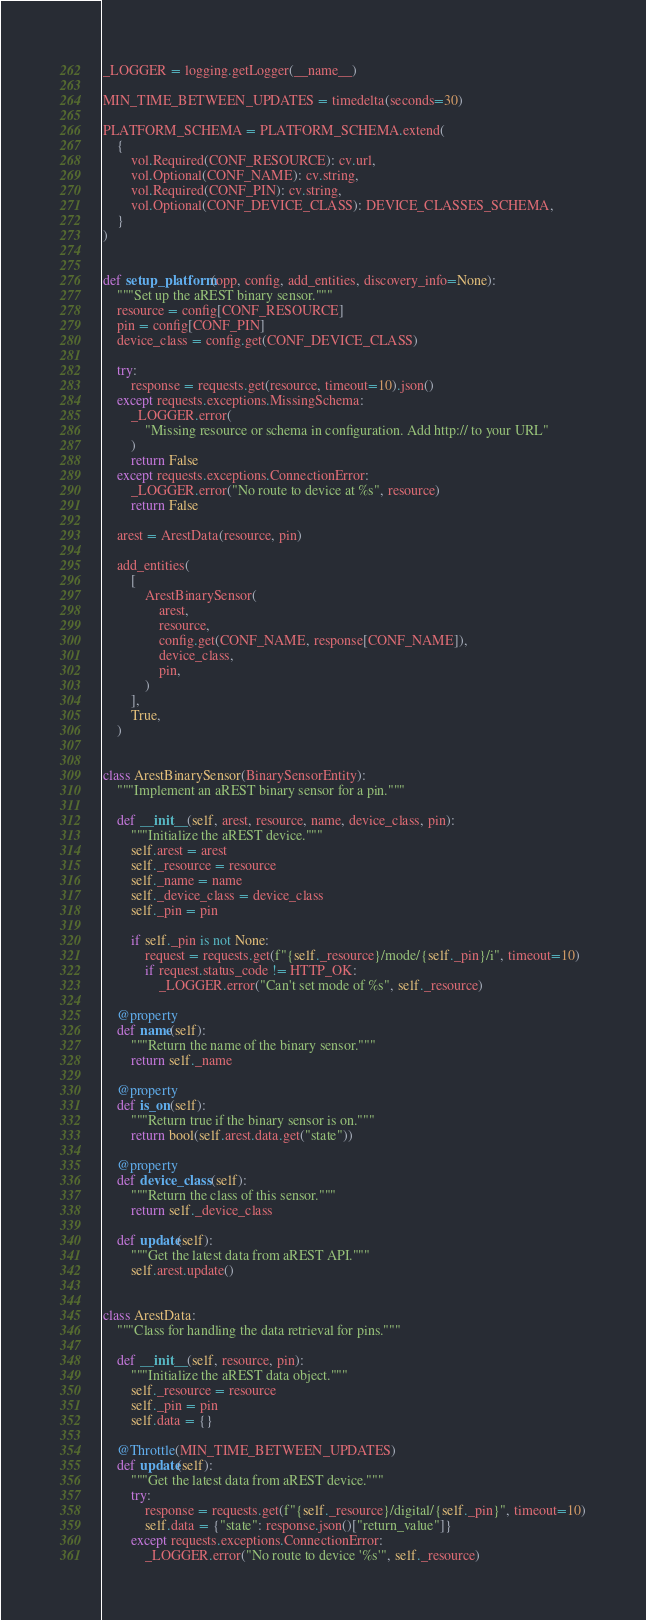<code> <loc_0><loc_0><loc_500><loc_500><_Python_>
_LOGGER = logging.getLogger(__name__)

MIN_TIME_BETWEEN_UPDATES = timedelta(seconds=30)

PLATFORM_SCHEMA = PLATFORM_SCHEMA.extend(
    {
        vol.Required(CONF_RESOURCE): cv.url,
        vol.Optional(CONF_NAME): cv.string,
        vol.Required(CONF_PIN): cv.string,
        vol.Optional(CONF_DEVICE_CLASS): DEVICE_CLASSES_SCHEMA,
    }
)


def setup_platform(opp, config, add_entities, discovery_info=None):
    """Set up the aREST binary sensor."""
    resource = config[CONF_RESOURCE]
    pin = config[CONF_PIN]
    device_class = config.get(CONF_DEVICE_CLASS)

    try:
        response = requests.get(resource, timeout=10).json()
    except requests.exceptions.MissingSchema:
        _LOGGER.error(
            "Missing resource or schema in configuration. Add http:// to your URL"
        )
        return False
    except requests.exceptions.ConnectionError:
        _LOGGER.error("No route to device at %s", resource)
        return False

    arest = ArestData(resource, pin)

    add_entities(
        [
            ArestBinarySensor(
                arest,
                resource,
                config.get(CONF_NAME, response[CONF_NAME]),
                device_class,
                pin,
            )
        ],
        True,
    )


class ArestBinarySensor(BinarySensorEntity):
    """Implement an aREST binary sensor for a pin."""

    def __init__(self, arest, resource, name, device_class, pin):
        """Initialize the aREST device."""
        self.arest = arest
        self._resource = resource
        self._name = name
        self._device_class = device_class
        self._pin = pin

        if self._pin is not None:
            request = requests.get(f"{self._resource}/mode/{self._pin}/i", timeout=10)
            if request.status_code != HTTP_OK:
                _LOGGER.error("Can't set mode of %s", self._resource)

    @property
    def name(self):
        """Return the name of the binary sensor."""
        return self._name

    @property
    def is_on(self):
        """Return true if the binary sensor is on."""
        return bool(self.arest.data.get("state"))

    @property
    def device_class(self):
        """Return the class of this sensor."""
        return self._device_class

    def update(self):
        """Get the latest data from aREST API."""
        self.arest.update()


class ArestData:
    """Class for handling the data retrieval for pins."""

    def __init__(self, resource, pin):
        """Initialize the aREST data object."""
        self._resource = resource
        self._pin = pin
        self.data = {}

    @Throttle(MIN_TIME_BETWEEN_UPDATES)
    def update(self):
        """Get the latest data from aREST device."""
        try:
            response = requests.get(f"{self._resource}/digital/{self._pin}", timeout=10)
            self.data = {"state": response.json()["return_value"]}
        except requests.exceptions.ConnectionError:
            _LOGGER.error("No route to device '%s'", self._resource)
</code> 